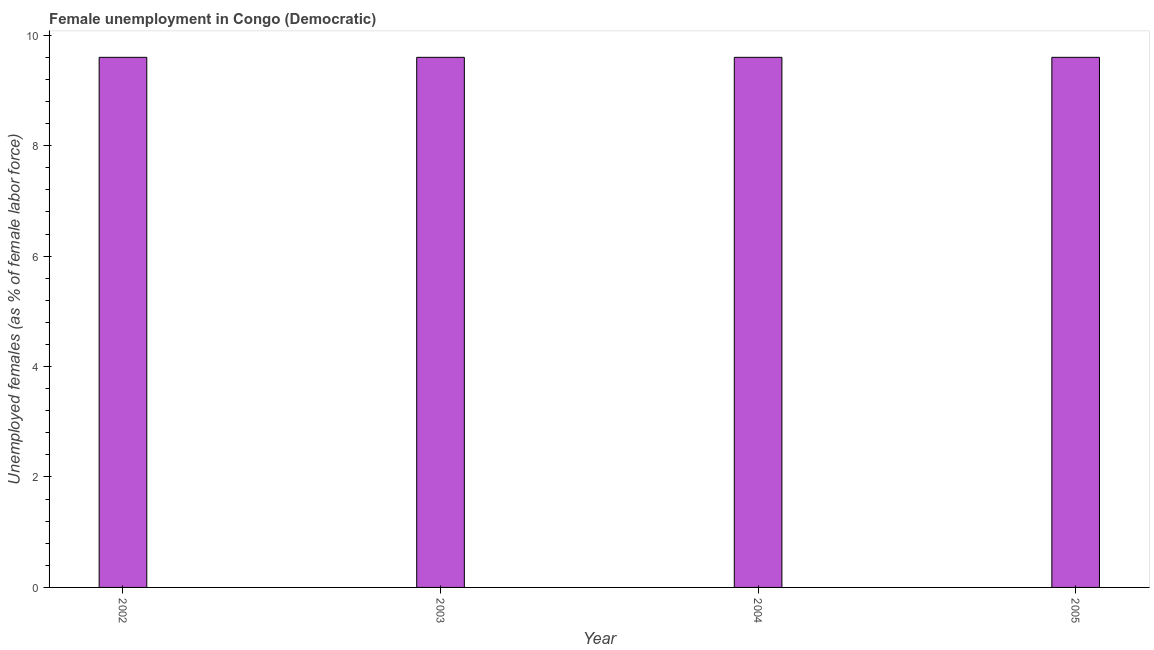Does the graph contain any zero values?
Provide a succinct answer. No. Does the graph contain grids?
Offer a very short reply. No. What is the title of the graph?
Your answer should be very brief. Female unemployment in Congo (Democratic). What is the label or title of the X-axis?
Your response must be concise. Year. What is the label or title of the Y-axis?
Offer a very short reply. Unemployed females (as % of female labor force). What is the unemployed females population in 2003?
Offer a terse response. 9.6. Across all years, what is the maximum unemployed females population?
Give a very brief answer. 9.6. Across all years, what is the minimum unemployed females population?
Make the answer very short. 9.6. In which year was the unemployed females population maximum?
Your response must be concise. 2002. What is the sum of the unemployed females population?
Provide a short and direct response. 38.4. What is the difference between the unemployed females population in 2002 and 2005?
Offer a very short reply. 0. What is the average unemployed females population per year?
Your answer should be very brief. 9.6. What is the median unemployed females population?
Your response must be concise. 9.6. Do a majority of the years between 2003 and 2004 (inclusive) have unemployed females population greater than 2.8 %?
Give a very brief answer. Yes. What is the ratio of the unemployed females population in 2002 to that in 2005?
Your answer should be compact. 1. What is the difference between the highest and the lowest unemployed females population?
Provide a short and direct response. 0. How many bars are there?
Provide a short and direct response. 4. What is the difference between two consecutive major ticks on the Y-axis?
Ensure brevity in your answer.  2. What is the Unemployed females (as % of female labor force) in 2002?
Make the answer very short. 9.6. What is the Unemployed females (as % of female labor force) of 2003?
Ensure brevity in your answer.  9.6. What is the Unemployed females (as % of female labor force) of 2004?
Provide a succinct answer. 9.6. What is the Unemployed females (as % of female labor force) in 2005?
Offer a terse response. 9.6. What is the difference between the Unemployed females (as % of female labor force) in 2002 and 2003?
Your response must be concise. 0. What is the difference between the Unemployed females (as % of female labor force) in 2002 and 2004?
Your response must be concise. 0. What is the difference between the Unemployed females (as % of female labor force) in 2002 and 2005?
Keep it short and to the point. 0. What is the difference between the Unemployed females (as % of female labor force) in 2003 and 2005?
Give a very brief answer. 0. What is the difference between the Unemployed females (as % of female labor force) in 2004 and 2005?
Provide a short and direct response. 0. What is the ratio of the Unemployed females (as % of female labor force) in 2002 to that in 2003?
Your response must be concise. 1. What is the ratio of the Unemployed females (as % of female labor force) in 2003 to that in 2004?
Keep it short and to the point. 1. What is the ratio of the Unemployed females (as % of female labor force) in 2004 to that in 2005?
Provide a short and direct response. 1. 